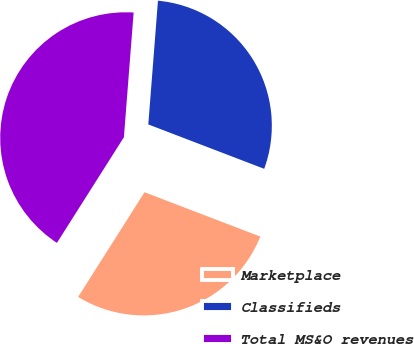Convert chart. <chart><loc_0><loc_0><loc_500><loc_500><pie_chart><fcel>Marketplace<fcel>Classifieds<fcel>Total MS&O revenues<nl><fcel>28.17%<fcel>29.58%<fcel>42.25%<nl></chart> 